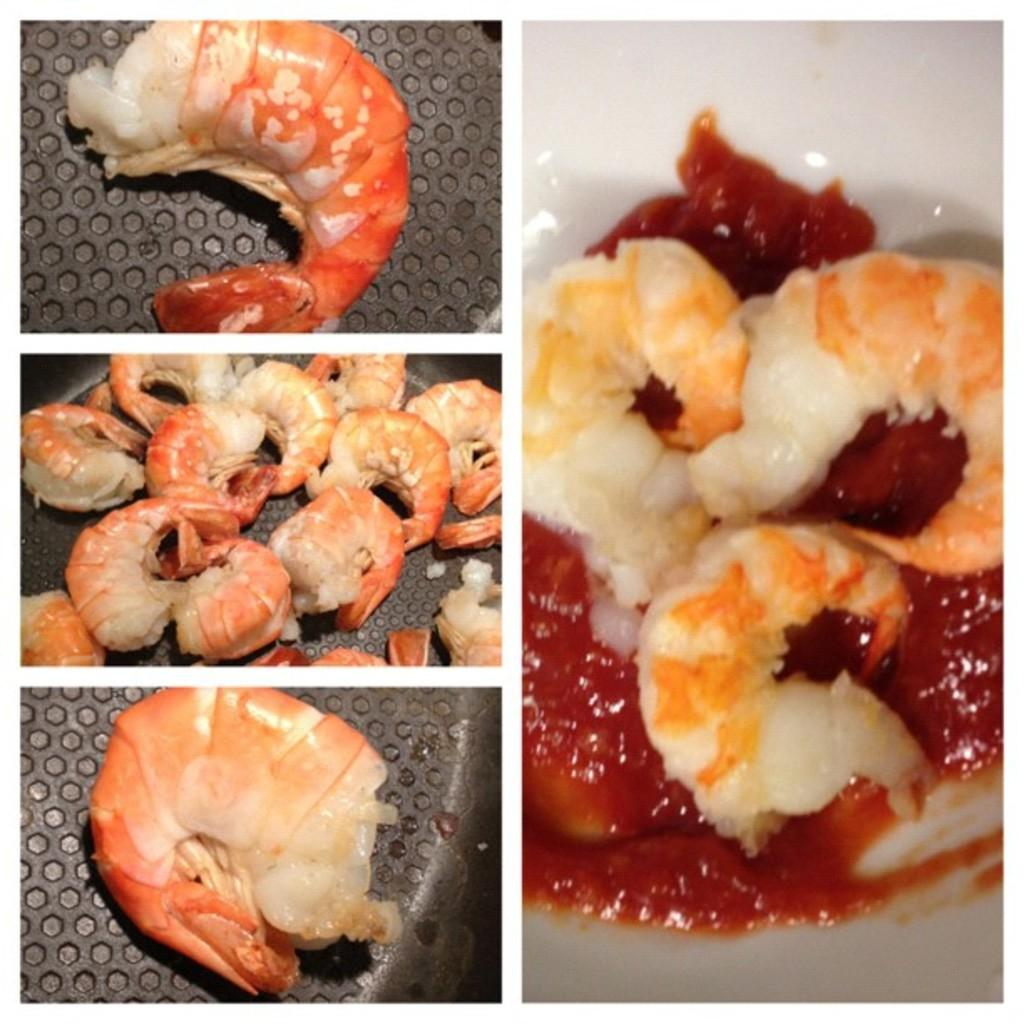What type of image is being displayed? The image is a photo grid. What can be seen in one of the photos within the grid? There are prawns in the sauce in the image. Where are the scissors located in the image? There are no scissors present in the image. What is the noise level in the image? The image does not convey any information about the noise level, as it is a still photo. 